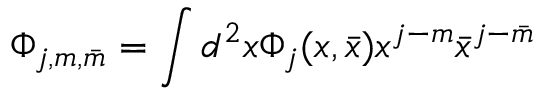Convert formula to latex. <formula><loc_0><loc_0><loc_500><loc_500>\Phi _ { j , m , \bar { m } } = \int d ^ { 2 } x \Phi _ { j } ( x , \bar { x } ) x ^ { j - m } \bar { x } ^ { j - \bar { m } }</formula> 